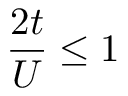Convert formula to latex. <formula><loc_0><loc_0><loc_500><loc_500>\frac { 2 t } { U } \leq 1</formula> 